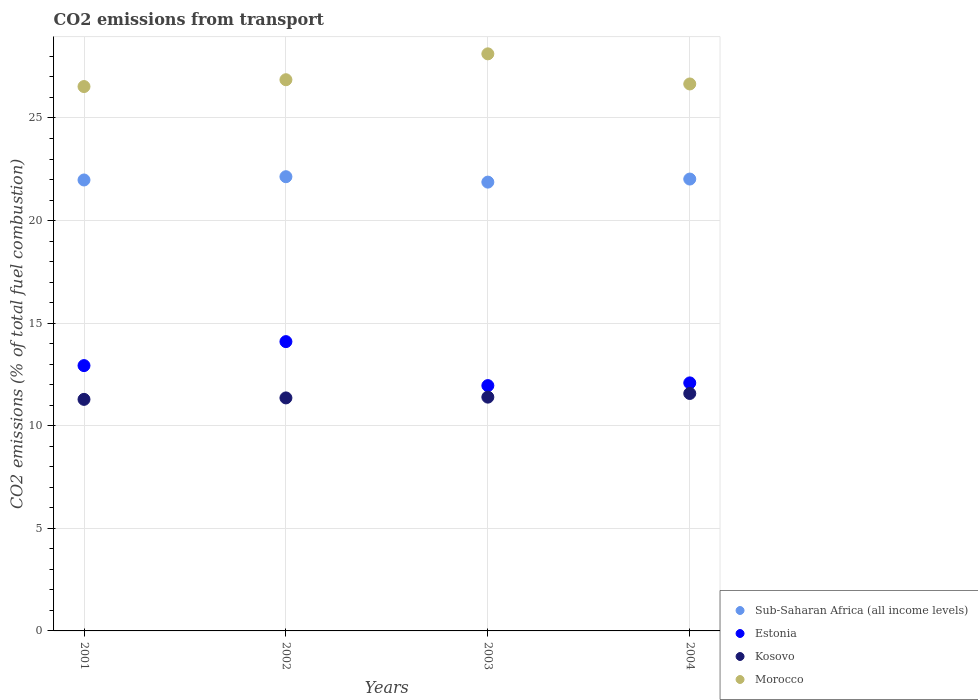What is the total CO2 emitted in Sub-Saharan Africa (all income levels) in 2003?
Make the answer very short. 21.87. Across all years, what is the maximum total CO2 emitted in Kosovo?
Keep it short and to the point. 11.57. Across all years, what is the minimum total CO2 emitted in Sub-Saharan Africa (all income levels)?
Your answer should be compact. 21.87. In which year was the total CO2 emitted in Morocco minimum?
Your response must be concise. 2001. What is the total total CO2 emitted in Morocco in the graph?
Offer a very short reply. 108.18. What is the difference between the total CO2 emitted in Kosovo in 2002 and that in 2003?
Provide a short and direct response. -0.04. What is the difference between the total CO2 emitted in Sub-Saharan Africa (all income levels) in 2003 and the total CO2 emitted in Kosovo in 2001?
Your answer should be compact. 10.59. What is the average total CO2 emitted in Morocco per year?
Provide a short and direct response. 27.04. In the year 2004, what is the difference between the total CO2 emitted in Estonia and total CO2 emitted in Sub-Saharan Africa (all income levels)?
Make the answer very short. -9.93. What is the ratio of the total CO2 emitted in Estonia in 2002 to that in 2003?
Ensure brevity in your answer.  1.18. What is the difference between the highest and the second highest total CO2 emitted in Sub-Saharan Africa (all income levels)?
Provide a succinct answer. 0.11. What is the difference between the highest and the lowest total CO2 emitted in Estonia?
Keep it short and to the point. 2.14. Is it the case that in every year, the sum of the total CO2 emitted in Kosovo and total CO2 emitted in Morocco  is greater than the sum of total CO2 emitted in Sub-Saharan Africa (all income levels) and total CO2 emitted in Estonia?
Ensure brevity in your answer.  No. Does the total CO2 emitted in Morocco monotonically increase over the years?
Your response must be concise. No. Is the total CO2 emitted in Sub-Saharan Africa (all income levels) strictly greater than the total CO2 emitted in Estonia over the years?
Your answer should be compact. Yes. Is the total CO2 emitted in Kosovo strictly less than the total CO2 emitted in Morocco over the years?
Provide a short and direct response. Yes. Does the graph contain grids?
Your answer should be very brief. Yes. How are the legend labels stacked?
Your response must be concise. Vertical. What is the title of the graph?
Make the answer very short. CO2 emissions from transport. Does "Ethiopia" appear as one of the legend labels in the graph?
Give a very brief answer. No. What is the label or title of the X-axis?
Keep it short and to the point. Years. What is the label or title of the Y-axis?
Provide a short and direct response. CO2 emissions (% of total fuel combustion). What is the CO2 emissions (% of total fuel combustion) in Sub-Saharan Africa (all income levels) in 2001?
Your answer should be very brief. 21.98. What is the CO2 emissions (% of total fuel combustion) of Estonia in 2001?
Your response must be concise. 12.93. What is the CO2 emissions (% of total fuel combustion) of Kosovo in 2001?
Ensure brevity in your answer.  11.29. What is the CO2 emissions (% of total fuel combustion) of Morocco in 2001?
Your response must be concise. 26.53. What is the CO2 emissions (% of total fuel combustion) in Sub-Saharan Africa (all income levels) in 2002?
Your answer should be very brief. 22.14. What is the CO2 emissions (% of total fuel combustion) in Estonia in 2002?
Offer a terse response. 14.1. What is the CO2 emissions (% of total fuel combustion) of Kosovo in 2002?
Your response must be concise. 11.36. What is the CO2 emissions (% of total fuel combustion) of Morocco in 2002?
Your answer should be compact. 26.86. What is the CO2 emissions (% of total fuel combustion) in Sub-Saharan Africa (all income levels) in 2003?
Your answer should be very brief. 21.87. What is the CO2 emissions (% of total fuel combustion) in Estonia in 2003?
Provide a short and direct response. 11.96. What is the CO2 emissions (% of total fuel combustion) of Kosovo in 2003?
Ensure brevity in your answer.  11.39. What is the CO2 emissions (% of total fuel combustion) of Morocco in 2003?
Your answer should be compact. 28.12. What is the CO2 emissions (% of total fuel combustion) of Sub-Saharan Africa (all income levels) in 2004?
Offer a terse response. 22.02. What is the CO2 emissions (% of total fuel combustion) of Estonia in 2004?
Provide a short and direct response. 12.09. What is the CO2 emissions (% of total fuel combustion) of Kosovo in 2004?
Your response must be concise. 11.57. What is the CO2 emissions (% of total fuel combustion) of Morocco in 2004?
Keep it short and to the point. 26.66. Across all years, what is the maximum CO2 emissions (% of total fuel combustion) of Sub-Saharan Africa (all income levels)?
Your answer should be very brief. 22.14. Across all years, what is the maximum CO2 emissions (% of total fuel combustion) of Estonia?
Provide a short and direct response. 14.1. Across all years, what is the maximum CO2 emissions (% of total fuel combustion) of Kosovo?
Keep it short and to the point. 11.57. Across all years, what is the maximum CO2 emissions (% of total fuel combustion) of Morocco?
Give a very brief answer. 28.12. Across all years, what is the minimum CO2 emissions (% of total fuel combustion) of Sub-Saharan Africa (all income levels)?
Ensure brevity in your answer.  21.87. Across all years, what is the minimum CO2 emissions (% of total fuel combustion) of Estonia?
Give a very brief answer. 11.96. Across all years, what is the minimum CO2 emissions (% of total fuel combustion) of Kosovo?
Your answer should be compact. 11.29. Across all years, what is the minimum CO2 emissions (% of total fuel combustion) of Morocco?
Offer a very short reply. 26.53. What is the total CO2 emissions (% of total fuel combustion) in Sub-Saharan Africa (all income levels) in the graph?
Provide a succinct answer. 88.01. What is the total CO2 emissions (% of total fuel combustion) in Estonia in the graph?
Offer a very short reply. 51.08. What is the total CO2 emissions (% of total fuel combustion) in Kosovo in the graph?
Provide a short and direct response. 45.61. What is the total CO2 emissions (% of total fuel combustion) of Morocco in the graph?
Offer a terse response. 108.18. What is the difference between the CO2 emissions (% of total fuel combustion) of Sub-Saharan Africa (all income levels) in 2001 and that in 2002?
Give a very brief answer. -0.16. What is the difference between the CO2 emissions (% of total fuel combustion) of Estonia in 2001 and that in 2002?
Your answer should be very brief. -1.17. What is the difference between the CO2 emissions (% of total fuel combustion) in Kosovo in 2001 and that in 2002?
Provide a short and direct response. -0.07. What is the difference between the CO2 emissions (% of total fuel combustion) in Morocco in 2001 and that in 2002?
Offer a very short reply. -0.33. What is the difference between the CO2 emissions (% of total fuel combustion) of Sub-Saharan Africa (all income levels) in 2001 and that in 2003?
Provide a succinct answer. 0.1. What is the difference between the CO2 emissions (% of total fuel combustion) in Estonia in 2001 and that in 2003?
Offer a terse response. 0.97. What is the difference between the CO2 emissions (% of total fuel combustion) in Kosovo in 2001 and that in 2003?
Make the answer very short. -0.11. What is the difference between the CO2 emissions (% of total fuel combustion) in Morocco in 2001 and that in 2003?
Keep it short and to the point. -1.59. What is the difference between the CO2 emissions (% of total fuel combustion) in Sub-Saharan Africa (all income levels) in 2001 and that in 2004?
Your answer should be compact. -0.05. What is the difference between the CO2 emissions (% of total fuel combustion) of Estonia in 2001 and that in 2004?
Your response must be concise. 0.84. What is the difference between the CO2 emissions (% of total fuel combustion) in Kosovo in 2001 and that in 2004?
Offer a terse response. -0.29. What is the difference between the CO2 emissions (% of total fuel combustion) of Morocco in 2001 and that in 2004?
Keep it short and to the point. -0.13. What is the difference between the CO2 emissions (% of total fuel combustion) in Sub-Saharan Africa (all income levels) in 2002 and that in 2003?
Keep it short and to the point. 0.26. What is the difference between the CO2 emissions (% of total fuel combustion) in Estonia in 2002 and that in 2003?
Provide a short and direct response. 2.14. What is the difference between the CO2 emissions (% of total fuel combustion) of Kosovo in 2002 and that in 2003?
Keep it short and to the point. -0.04. What is the difference between the CO2 emissions (% of total fuel combustion) in Morocco in 2002 and that in 2003?
Your response must be concise. -1.26. What is the difference between the CO2 emissions (% of total fuel combustion) of Sub-Saharan Africa (all income levels) in 2002 and that in 2004?
Your answer should be very brief. 0.11. What is the difference between the CO2 emissions (% of total fuel combustion) of Estonia in 2002 and that in 2004?
Offer a very short reply. 2.01. What is the difference between the CO2 emissions (% of total fuel combustion) in Kosovo in 2002 and that in 2004?
Make the answer very short. -0.22. What is the difference between the CO2 emissions (% of total fuel combustion) in Morocco in 2002 and that in 2004?
Your answer should be very brief. 0.21. What is the difference between the CO2 emissions (% of total fuel combustion) in Sub-Saharan Africa (all income levels) in 2003 and that in 2004?
Make the answer very short. -0.15. What is the difference between the CO2 emissions (% of total fuel combustion) of Estonia in 2003 and that in 2004?
Offer a very short reply. -0.13. What is the difference between the CO2 emissions (% of total fuel combustion) in Kosovo in 2003 and that in 2004?
Provide a short and direct response. -0.18. What is the difference between the CO2 emissions (% of total fuel combustion) of Morocco in 2003 and that in 2004?
Your response must be concise. 1.47. What is the difference between the CO2 emissions (% of total fuel combustion) of Sub-Saharan Africa (all income levels) in 2001 and the CO2 emissions (% of total fuel combustion) of Estonia in 2002?
Keep it short and to the point. 7.88. What is the difference between the CO2 emissions (% of total fuel combustion) of Sub-Saharan Africa (all income levels) in 2001 and the CO2 emissions (% of total fuel combustion) of Kosovo in 2002?
Provide a succinct answer. 10.62. What is the difference between the CO2 emissions (% of total fuel combustion) in Sub-Saharan Africa (all income levels) in 2001 and the CO2 emissions (% of total fuel combustion) in Morocco in 2002?
Ensure brevity in your answer.  -4.89. What is the difference between the CO2 emissions (% of total fuel combustion) of Estonia in 2001 and the CO2 emissions (% of total fuel combustion) of Kosovo in 2002?
Provide a succinct answer. 1.57. What is the difference between the CO2 emissions (% of total fuel combustion) in Estonia in 2001 and the CO2 emissions (% of total fuel combustion) in Morocco in 2002?
Ensure brevity in your answer.  -13.93. What is the difference between the CO2 emissions (% of total fuel combustion) in Kosovo in 2001 and the CO2 emissions (% of total fuel combustion) in Morocco in 2002?
Offer a terse response. -15.58. What is the difference between the CO2 emissions (% of total fuel combustion) in Sub-Saharan Africa (all income levels) in 2001 and the CO2 emissions (% of total fuel combustion) in Estonia in 2003?
Make the answer very short. 10.02. What is the difference between the CO2 emissions (% of total fuel combustion) in Sub-Saharan Africa (all income levels) in 2001 and the CO2 emissions (% of total fuel combustion) in Kosovo in 2003?
Make the answer very short. 10.58. What is the difference between the CO2 emissions (% of total fuel combustion) of Sub-Saharan Africa (all income levels) in 2001 and the CO2 emissions (% of total fuel combustion) of Morocco in 2003?
Your answer should be very brief. -6.15. What is the difference between the CO2 emissions (% of total fuel combustion) in Estonia in 2001 and the CO2 emissions (% of total fuel combustion) in Kosovo in 2003?
Your answer should be very brief. 1.54. What is the difference between the CO2 emissions (% of total fuel combustion) in Estonia in 2001 and the CO2 emissions (% of total fuel combustion) in Morocco in 2003?
Provide a short and direct response. -15.19. What is the difference between the CO2 emissions (% of total fuel combustion) in Kosovo in 2001 and the CO2 emissions (% of total fuel combustion) in Morocco in 2003?
Your answer should be very brief. -16.84. What is the difference between the CO2 emissions (% of total fuel combustion) of Sub-Saharan Africa (all income levels) in 2001 and the CO2 emissions (% of total fuel combustion) of Estonia in 2004?
Provide a succinct answer. 9.89. What is the difference between the CO2 emissions (% of total fuel combustion) of Sub-Saharan Africa (all income levels) in 2001 and the CO2 emissions (% of total fuel combustion) of Kosovo in 2004?
Provide a short and direct response. 10.41. What is the difference between the CO2 emissions (% of total fuel combustion) in Sub-Saharan Africa (all income levels) in 2001 and the CO2 emissions (% of total fuel combustion) in Morocco in 2004?
Give a very brief answer. -4.68. What is the difference between the CO2 emissions (% of total fuel combustion) in Estonia in 2001 and the CO2 emissions (% of total fuel combustion) in Kosovo in 2004?
Ensure brevity in your answer.  1.36. What is the difference between the CO2 emissions (% of total fuel combustion) of Estonia in 2001 and the CO2 emissions (% of total fuel combustion) of Morocco in 2004?
Provide a succinct answer. -13.73. What is the difference between the CO2 emissions (% of total fuel combustion) in Kosovo in 2001 and the CO2 emissions (% of total fuel combustion) in Morocco in 2004?
Make the answer very short. -15.37. What is the difference between the CO2 emissions (% of total fuel combustion) in Sub-Saharan Africa (all income levels) in 2002 and the CO2 emissions (% of total fuel combustion) in Estonia in 2003?
Keep it short and to the point. 10.18. What is the difference between the CO2 emissions (% of total fuel combustion) of Sub-Saharan Africa (all income levels) in 2002 and the CO2 emissions (% of total fuel combustion) of Kosovo in 2003?
Provide a succinct answer. 10.74. What is the difference between the CO2 emissions (% of total fuel combustion) of Sub-Saharan Africa (all income levels) in 2002 and the CO2 emissions (% of total fuel combustion) of Morocco in 2003?
Keep it short and to the point. -5.99. What is the difference between the CO2 emissions (% of total fuel combustion) in Estonia in 2002 and the CO2 emissions (% of total fuel combustion) in Kosovo in 2003?
Provide a succinct answer. 2.71. What is the difference between the CO2 emissions (% of total fuel combustion) in Estonia in 2002 and the CO2 emissions (% of total fuel combustion) in Morocco in 2003?
Your answer should be compact. -14.03. What is the difference between the CO2 emissions (% of total fuel combustion) in Kosovo in 2002 and the CO2 emissions (% of total fuel combustion) in Morocco in 2003?
Your answer should be very brief. -16.77. What is the difference between the CO2 emissions (% of total fuel combustion) of Sub-Saharan Africa (all income levels) in 2002 and the CO2 emissions (% of total fuel combustion) of Estonia in 2004?
Keep it short and to the point. 10.05. What is the difference between the CO2 emissions (% of total fuel combustion) in Sub-Saharan Africa (all income levels) in 2002 and the CO2 emissions (% of total fuel combustion) in Kosovo in 2004?
Keep it short and to the point. 10.56. What is the difference between the CO2 emissions (% of total fuel combustion) in Sub-Saharan Africa (all income levels) in 2002 and the CO2 emissions (% of total fuel combustion) in Morocco in 2004?
Ensure brevity in your answer.  -4.52. What is the difference between the CO2 emissions (% of total fuel combustion) in Estonia in 2002 and the CO2 emissions (% of total fuel combustion) in Kosovo in 2004?
Keep it short and to the point. 2.53. What is the difference between the CO2 emissions (% of total fuel combustion) in Estonia in 2002 and the CO2 emissions (% of total fuel combustion) in Morocco in 2004?
Provide a succinct answer. -12.56. What is the difference between the CO2 emissions (% of total fuel combustion) of Kosovo in 2002 and the CO2 emissions (% of total fuel combustion) of Morocco in 2004?
Your answer should be compact. -15.3. What is the difference between the CO2 emissions (% of total fuel combustion) in Sub-Saharan Africa (all income levels) in 2003 and the CO2 emissions (% of total fuel combustion) in Estonia in 2004?
Offer a terse response. 9.79. What is the difference between the CO2 emissions (% of total fuel combustion) of Sub-Saharan Africa (all income levels) in 2003 and the CO2 emissions (% of total fuel combustion) of Kosovo in 2004?
Your response must be concise. 10.3. What is the difference between the CO2 emissions (% of total fuel combustion) of Sub-Saharan Africa (all income levels) in 2003 and the CO2 emissions (% of total fuel combustion) of Morocco in 2004?
Keep it short and to the point. -4.78. What is the difference between the CO2 emissions (% of total fuel combustion) in Estonia in 2003 and the CO2 emissions (% of total fuel combustion) in Kosovo in 2004?
Keep it short and to the point. 0.38. What is the difference between the CO2 emissions (% of total fuel combustion) of Estonia in 2003 and the CO2 emissions (% of total fuel combustion) of Morocco in 2004?
Make the answer very short. -14.7. What is the difference between the CO2 emissions (% of total fuel combustion) in Kosovo in 2003 and the CO2 emissions (% of total fuel combustion) in Morocco in 2004?
Your response must be concise. -15.26. What is the average CO2 emissions (% of total fuel combustion) in Sub-Saharan Africa (all income levels) per year?
Provide a succinct answer. 22. What is the average CO2 emissions (% of total fuel combustion) in Estonia per year?
Provide a succinct answer. 12.77. What is the average CO2 emissions (% of total fuel combustion) of Kosovo per year?
Give a very brief answer. 11.4. What is the average CO2 emissions (% of total fuel combustion) in Morocco per year?
Make the answer very short. 27.04. In the year 2001, what is the difference between the CO2 emissions (% of total fuel combustion) of Sub-Saharan Africa (all income levels) and CO2 emissions (% of total fuel combustion) of Estonia?
Ensure brevity in your answer.  9.05. In the year 2001, what is the difference between the CO2 emissions (% of total fuel combustion) of Sub-Saharan Africa (all income levels) and CO2 emissions (% of total fuel combustion) of Kosovo?
Ensure brevity in your answer.  10.69. In the year 2001, what is the difference between the CO2 emissions (% of total fuel combustion) of Sub-Saharan Africa (all income levels) and CO2 emissions (% of total fuel combustion) of Morocco?
Keep it short and to the point. -4.55. In the year 2001, what is the difference between the CO2 emissions (% of total fuel combustion) in Estonia and CO2 emissions (% of total fuel combustion) in Kosovo?
Provide a short and direct response. 1.65. In the year 2001, what is the difference between the CO2 emissions (% of total fuel combustion) in Estonia and CO2 emissions (% of total fuel combustion) in Morocco?
Keep it short and to the point. -13.6. In the year 2001, what is the difference between the CO2 emissions (% of total fuel combustion) of Kosovo and CO2 emissions (% of total fuel combustion) of Morocco?
Offer a very short reply. -15.25. In the year 2002, what is the difference between the CO2 emissions (% of total fuel combustion) of Sub-Saharan Africa (all income levels) and CO2 emissions (% of total fuel combustion) of Estonia?
Give a very brief answer. 8.04. In the year 2002, what is the difference between the CO2 emissions (% of total fuel combustion) in Sub-Saharan Africa (all income levels) and CO2 emissions (% of total fuel combustion) in Kosovo?
Offer a very short reply. 10.78. In the year 2002, what is the difference between the CO2 emissions (% of total fuel combustion) in Sub-Saharan Africa (all income levels) and CO2 emissions (% of total fuel combustion) in Morocco?
Keep it short and to the point. -4.73. In the year 2002, what is the difference between the CO2 emissions (% of total fuel combustion) of Estonia and CO2 emissions (% of total fuel combustion) of Kosovo?
Ensure brevity in your answer.  2.74. In the year 2002, what is the difference between the CO2 emissions (% of total fuel combustion) in Estonia and CO2 emissions (% of total fuel combustion) in Morocco?
Make the answer very short. -12.76. In the year 2002, what is the difference between the CO2 emissions (% of total fuel combustion) in Kosovo and CO2 emissions (% of total fuel combustion) in Morocco?
Give a very brief answer. -15.51. In the year 2003, what is the difference between the CO2 emissions (% of total fuel combustion) of Sub-Saharan Africa (all income levels) and CO2 emissions (% of total fuel combustion) of Estonia?
Your answer should be very brief. 9.92. In the year 2003, what is the difference between the CO2 emissions (% of total fuel combustion) of Sub-Saharan Africa (all income levels) and CO2 emissions (% of total fuel combustion) of Kosovo?
Provide a short and direct response. 10.48. In the year 2003, what is the difference between the CO2 emissions (% of total fuel combustion) of Sub-Saharan Africa (all income levels) and CO2 emissions (% of total fuel combustion) of Morocco?
Provide a short and direct response. -6.25. In the year 2003, what is the difference between the CO2 emissions (% of total fuel combustion) of Estonia and CO2 emissions (% of total fuel combustion) of Kosovo?
Provide a succinct answer. 0.56. In the year 2003, what is the difference between the CO2 emissions (% of total fuel combustion) in Estonia and CO2 emissions (% of total fuel combustion) in Morocco?
Offer a terse response. -16.17. In the year 2003, what is the difference between the CO2 emissions (% of total fuel combustion) of Kosovo and CO2 emissions (% of total fuel combustion) of Morocco?
Offer a terse response. -16.73. In the year 2004, what is the difference between the CO2 emissions (% of total fuel combustion) in Sub-Saharan Africa (all income levels) and CO2 emissions (% of total fuel combustion) in Estonia?
Make the answer very short. 9.93. In the year 2004, what is the difference between the CO2 emissions (% of total fuel combustion) in Sub-Saharan Africa (all income levels) and CO2 emissions (% of total fuel combustion) in Kosovo?
Ensure brevity in your answer.  10.45. In the year 2004, what is the difference between the CO2 emissions (% of total fuel combustion) of Sub-Saharan Africa (all income levels) and CO2 emissions (% of total fuel combustion) of Morocco?
Your response must be concise. -4.63. In the year 2004, what is the difference between the CO2 emissions (% of total fuel combustion) of Estonia and CO2 emissions (% of total fuel combustion) of Kosovo?
Offer a very short reply. 0.52. In the year 2004, what is the difference between the CO2 emissions (% of total fuel combustion) of Estonia and CO2 emissions (% of total fuel combustion) of Morocco?
Offer a terse response. -14.57. In the year 2004, what is the difference between the CO2 emissions (% of total fuel combustion) in Kosovo and CO2 emissions (% of total fuel combustion) in Morocco?
Ensure brevity in your answer.  -15.08. What is the ratio of the CO2 emissions (% of total fuel combustion) of Estonia in 2001 to that in 2002?
Offer a terse response. 0.92. What is the ratio of the CO2 emissions (% of total fuel combustion) of Morocco in 2001 to that in 2002?
Your response must be concise. 0.99. What is the ratio of the CO2 emissions (% of total fuel combustion) of Sub-Saharan Africa (all income levels) in 2001 to that in 2003?
Your response must be concise. 1. What is the ratio of the CO2 emissions (% of total fuel combustion) of Estonia in 2001 to that in 2003?
Your response must be concise. 1.08. What is the ratio of the CO2 emissions (% of total fuel combustion) in Morocco in 2001 to that in 2003?
Keep it short and to the point. 0.94. What is the ratio of the CO2 emissions (% of total fuel combustion) of Sub-Saharan Africa (all income levels) in 2001 to that in 2004?
Make the answer very short. 1. What is the ratio of the CO2 emissions (% of total fuel combustion) in Estonia in 2001 to that in 2004?
Offer a very short reply. 1.07. What is the ratio of the CO2 emissions (% of total fuel combustion) of Kosovo in 2001 to that in 2004?
Offer a terse response. 0.98. What is the ratio of the CO2 emissions (% of total fuel combustion) of Sub-Saharan Africa (all income levels) in 2002 to that in 2003?
Give a very brief answer. 1.01. What is the ratio of the CO2 emissions (% of total fuel combustion) in Estonia in 2002 to that in 2003?
Your answer should be very brief. 1.18. What is the ratio of the CO2 emissions (% of total fuel combustion) in Morocco in 2002 to that in 2003?
Provide a succinct answer. 0.96. What is the ratio of the CO2 emissions (% of total fuel combustion) of Estonia in 2002 to that in 2004?
Your answer should be very brief. 1.17. What is the ratio of the CO2 emissions (% of total fuel combustion) of Kosovo in 2002 to that in 2004?
Your answer should be very brief. 0.98. What is the ratio of the CO2 emissions (% of total fuel combustion) in Morocco in 2002 to that in 2004?
Provide a succinct answer. 1.01. What is the ratio of the CO2 emissions (% of total fuel combustion) of Sub-Saharan Africa (all income levels) in 2003 to that in 2004?
Offer a terse response. 0.99. What is the ratio of the CO2 emissions (% of total fuel combustion) in Kosovo in 2003 to that in 2004?
Your response must be concise. 0.98. What is the ratio of the CO2 emissions (% of total fuel combustion) in Morocco in 2003 to that in 2004?
Ensure brevity in your answer.  1.06. What is the difference between the highest and the second highest CO2 emissions (% of total fuel combustion) in Sub-Saharan Africa (all income levels)?
Give a very brief answer. 0.11. What is the difference between the highest and the second highest CO2 emissions (% of total fuel combustion) of Estonia?
Make the answer very short. 1.17. What is the difference between the highest and the second highest CO2 emissions (% of total fuel combustion) in Kosovo?
Your response must be concise. 0.18. What is the difference between the highest and the second highest CO2 emissions (% of total fuel combustion) in Morocco?
Your answer should be very brief. 1.26. What is the difference between the highest and the lowest CO2 emissions (% of total fuel combustion) in Sub-Saharan Africa (all income levels)?
Give a very brief answer. 0.26. What is the difference between the highest and the lowest CO2 emissions (% of total fuel combustion) in Estonia?
Your response must be concise. 2.14. What is the difference between the highest and the lowest CO2 emissions (% of total fuel combustion) of Kosovo?
Keep it short and to the point. 0.29. What is the difference between the highest and the lowest CO2 emissions (% of total fuel combustion) of Morocco?
Provide a succinct answer. 1.59. 